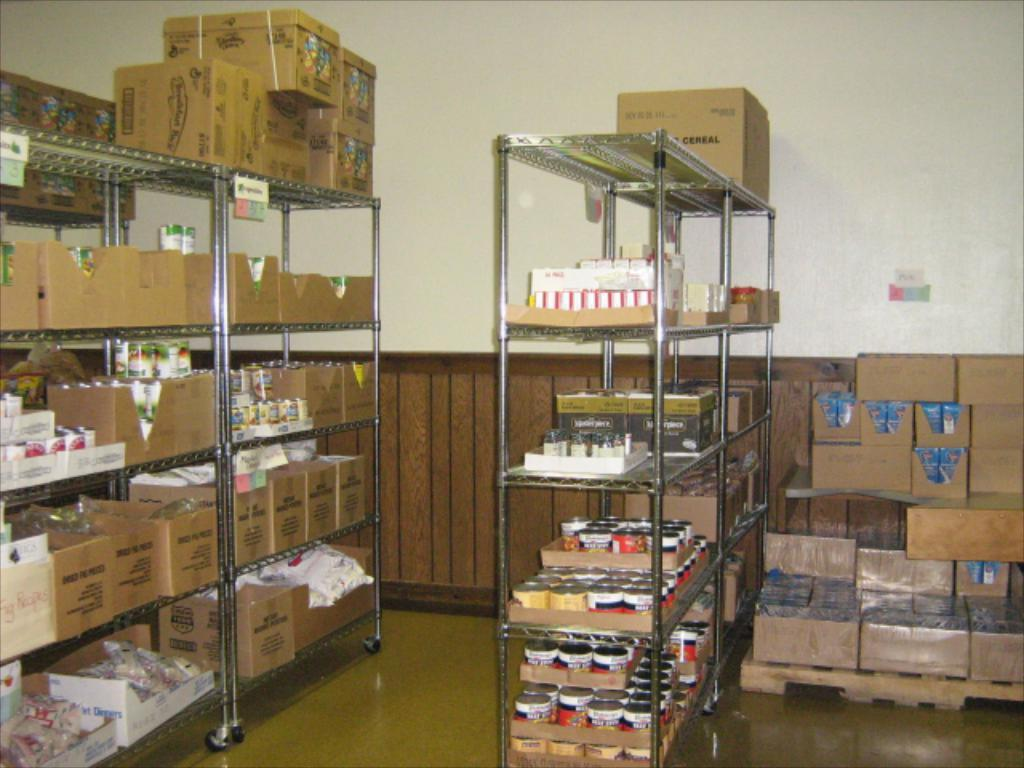What types of containers are visible in the image? There are boxes, jars, and packets in the image. Where are the boxes, jars, and packets located? They are on racks in the image. What is the position of the racks in the image? The racks are on the floor. What can be seen in the background of the image? There is a wall and objects visible in the background. Can you tell me how many frogs are sitting on the boxes in the image? There are no frogs present in the image; it only features boxes, jars, and packets on racks. 